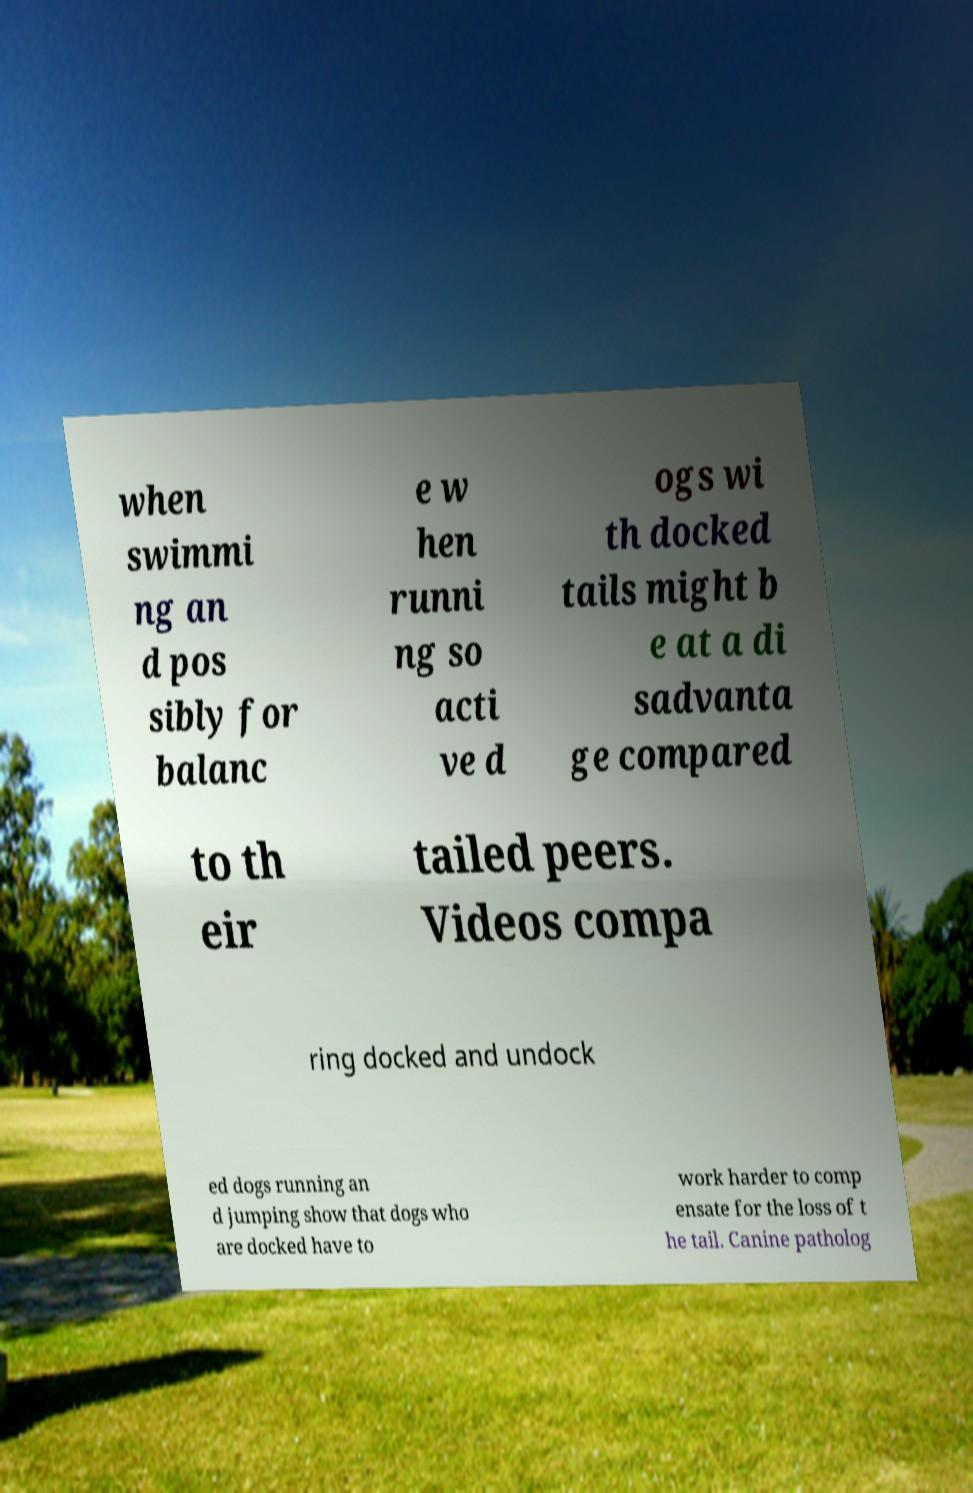There's text embedded in this image that I need extracted. Can you transcribe it verbatim? when swimmi ng an d pos sibly for balanc e w hen runni ng so acti ve d ogs wi th docked tails might b e at a di sadvanta ge compared to th eir tailed peers. Videos compa ring docked and undock ed dogs running an d jumping show that dogs who are docked have to work harder to comp ensate for the loss of t he tail. Canine patholog 